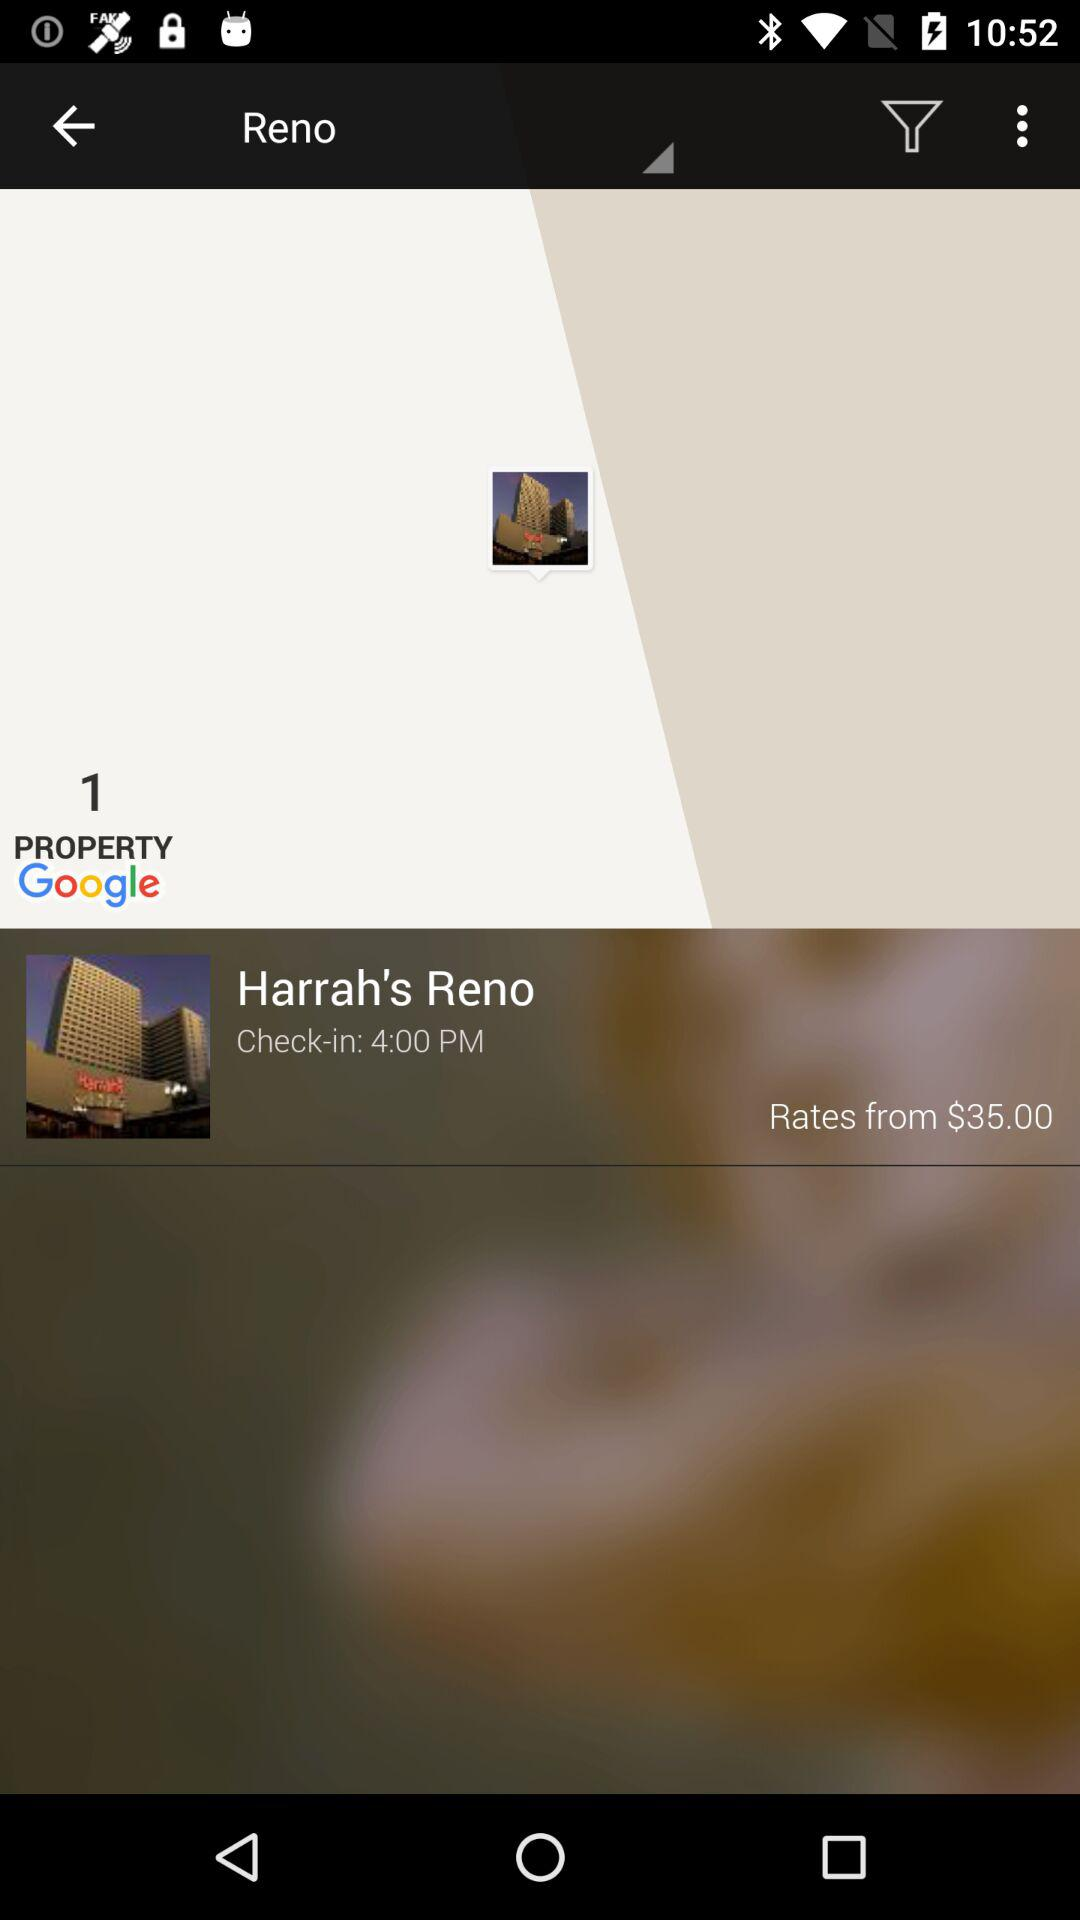How much is the price range of the hotel?
Answer the question using a single word or phrase. $35.00 